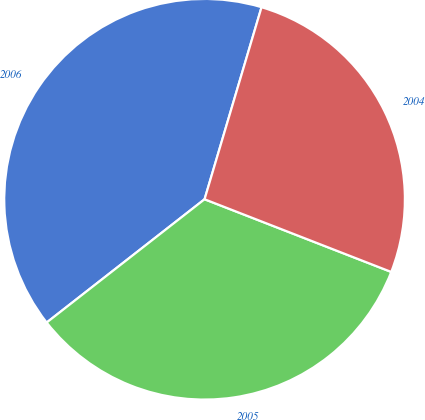<chart> <loc_0><loc_0><loc_500><loc_500><pie_chart><fcel>2006<fcel>2005<fcel>2004<nl><fcel>40.14%<fcel>33.54%<fcel>26.32%<nl></chart> 